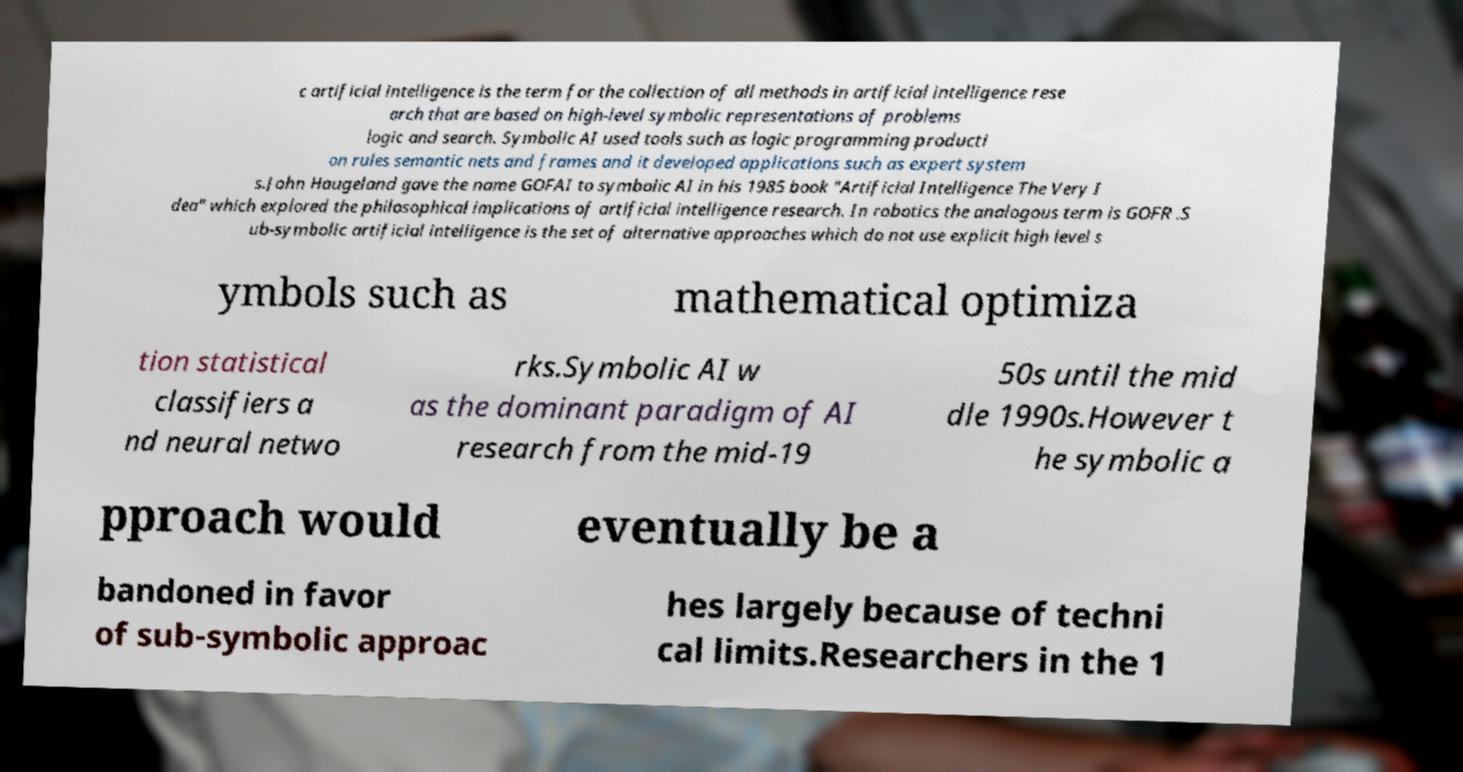Can you read and provide the text displayed in the image?This photo seems to have some interesting text. Can you extract and type it out for me? c artificial intelligence is the term for the collection of all methods in artificial intelligence rese arch that are based on high-level symbolic representations of problems logic and search. Symbolic AI used tools such as logic programming producti on rules semantic nets and frames and it developed applications such as expert system s.John Haugeland gave the name GOFAI to symbolic AI in his 1985 book "Artificial Intelligence The Very I dea" which explored the philosophical implications of artificial intelligence research. In robotics the analogous term is GOFR .S ub-symbolic artificial intelligence is the set of alternative approaches which do not use explicit high level s ymbols such as mathematical optimiza tion statistical classifiers a nd neural netwo rks.Symbolic AI w as the dominant paradigm of AI research from the mid-19 50s until the mid dle 1990s.However t he symbolic a pproach would eventually be a bandoned in favor of sub-symbolic approac hes largely because of techni cal limits.Researchers in the 1 